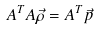Convert formula to latex. <formula><loc_0><loc_0><loc_500><loc_500>A ^ { T } A \vec { \rho } = A ^ { T } \vec { p }</formula> 